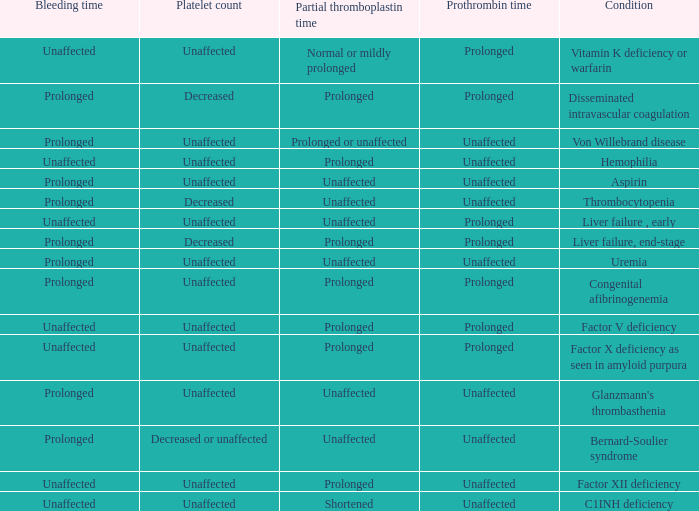Which Condition has a Bleeding time of unaffected, and a Partial thromboplastin time of prolonged, and a Prothrombin time of unaffected? Hemophilia, Factor XII deficiency. 